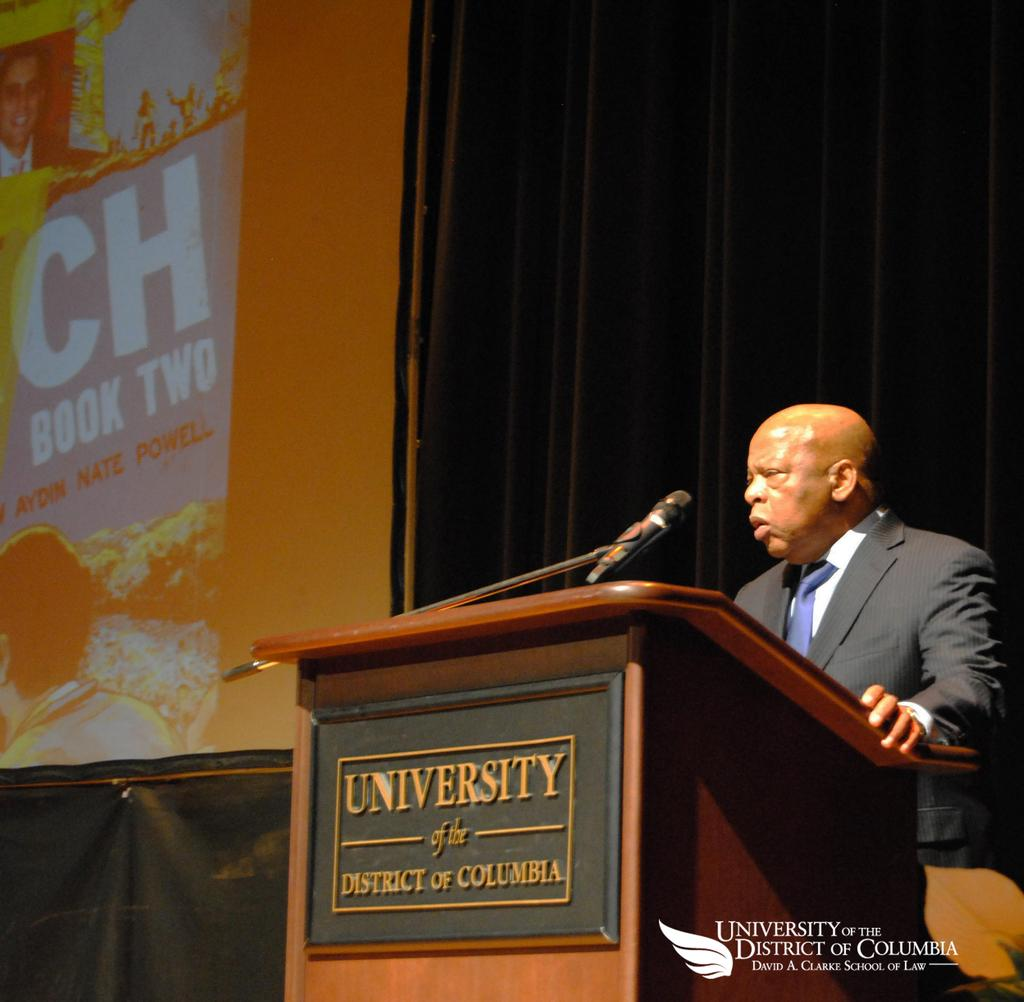Who is the person in the image? There is a man in the image. What is the man doing in the image? The man is talking on a microphone. What object is present in the image that the man might be using for support or display? There is a podium in the image. What can be seen in the background of the image? There is a curtain and a screen in the background of the image. What type of mint is growing on the podium in the image? There is no mint growing on the podium in the image. What date is displayed on the calendar in the image? There is no calendar present in the image. 